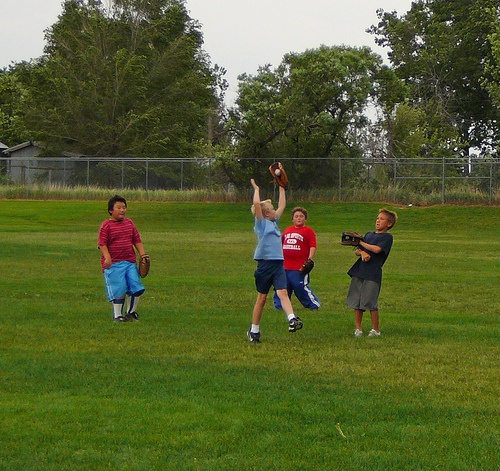Describe the objects in this image and their specific colors. I can see people in lightgray, black, darkgreen, and gray tones, people in lightgray, black, darkgreen, maroon, and gray tones, people in lightgray, maroon, teal, brown, and black tones, people in lightgray, brown, black, navy, and maroon tones, and baseball glove in lightgray, maroon, black, and brown tones in this image. 